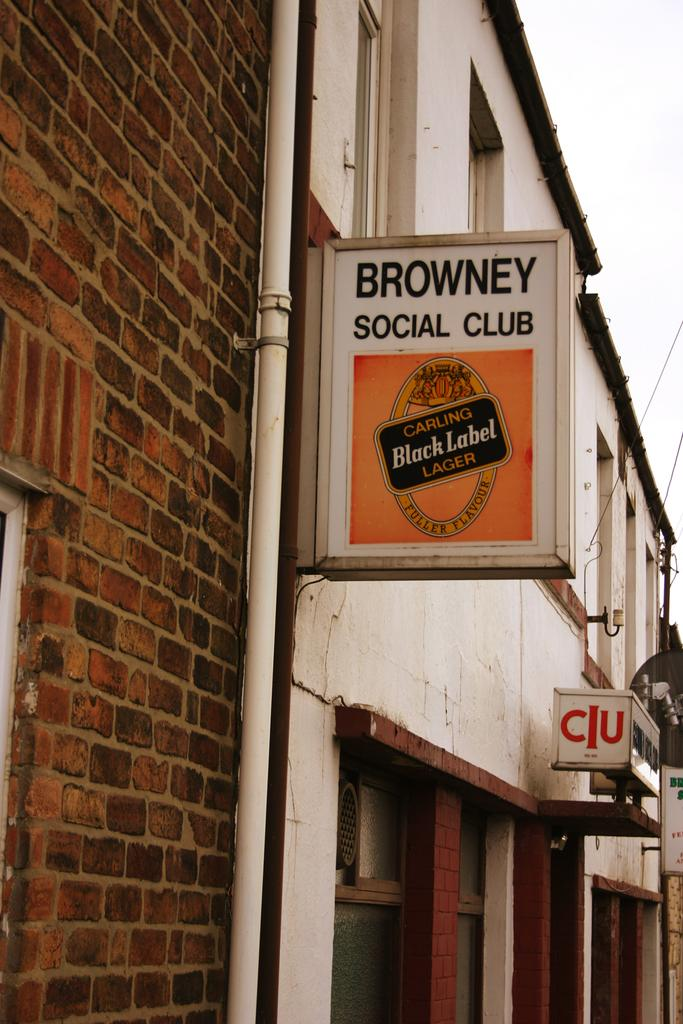What can be seen in the sky in the image? The sky is visible in the image, but no specific details about the sky can be determined from the provided facts. What type of structure is present in the image? There is a brick wall and a building in the image. What other objects can be seen in the image? There is a pipe, boards, and lights visible in the image. Can you see any fangs in the image? There are no fangs present in the image. Is this image taken at an airport? The provided facts do not mention anything about an airport, so it cannot be determined from the image. 